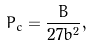Convert formula to latex. <formula><loc_0><loc_0><loc_500><loc_500>P _ { c } = \frac { B } { 2 7 b ^ { 2 } } ,</formula> 